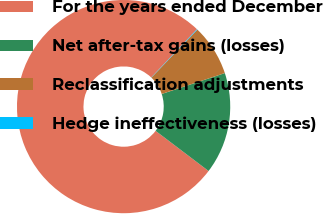Convert chart. <chart><loc_0><loc_0><loc_500><loc_500><pie_chart><fcel>For the years ended December<fcel>Net after-tax gains (losses)<fcel>Reclassification adjustments<fcel>Hedge ineffectiveness (losses)<nl><fcel>76.76%<fcel>15.41%<fcel>7.75%<fcel>0.08%<nl></chart> 